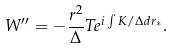Convert formula to latex. <formula><loc_0><loc_0><loc_500><loc_500>W ^ { \prime \prime } = - \frac { r ^ { 2 } } { \Delta } T e ^ { i \int K / \Delta d r _ { * } } .</formula> 